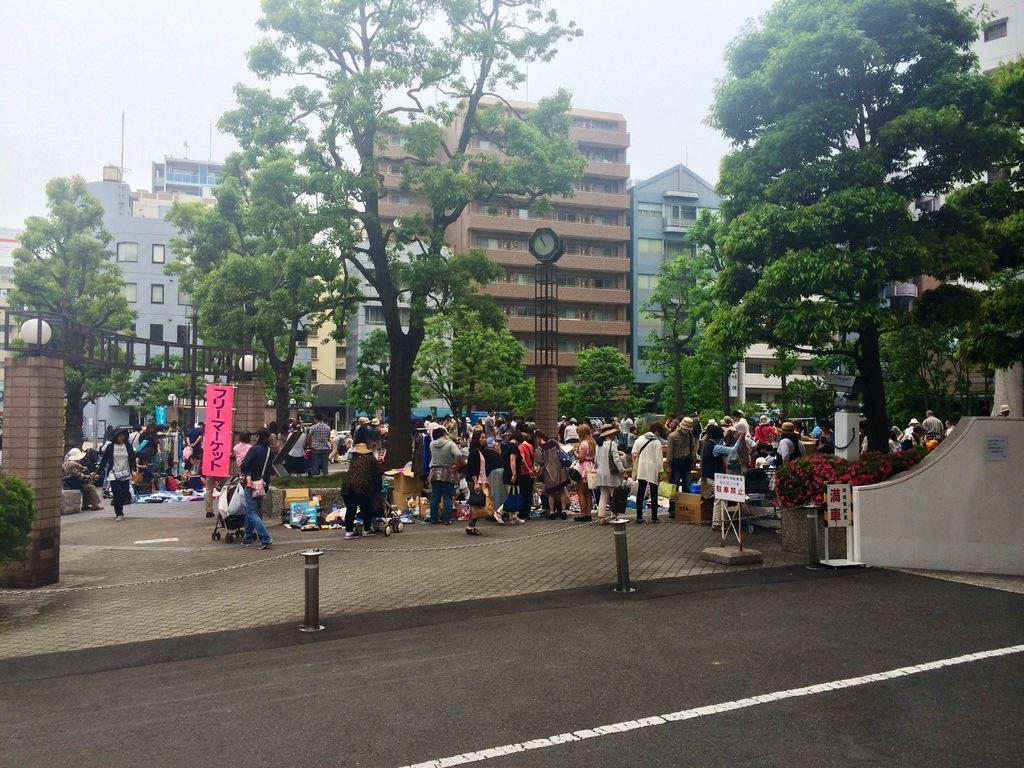In one or two sentences, can you explain what this image depicts? In the picture we can see a part of the road and behind it, we can see a path with many people are standing and some are sitting and we can also see some trees and in the background we can see some buildings with many floors and a part of the sky. 